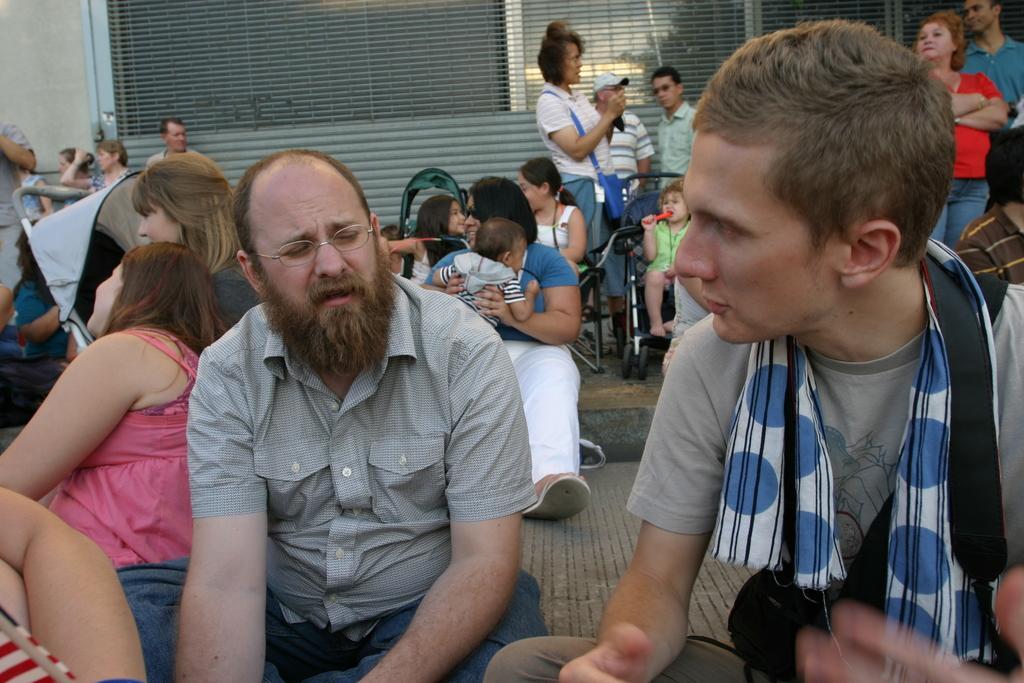In one or two sentences, can you explain what this image depicts? In this image we can see a few people sitting on the ground and a few people standing and holding objects. And we can see a child on the chair and holding an object. In the background, we can see the wall with shutters. 